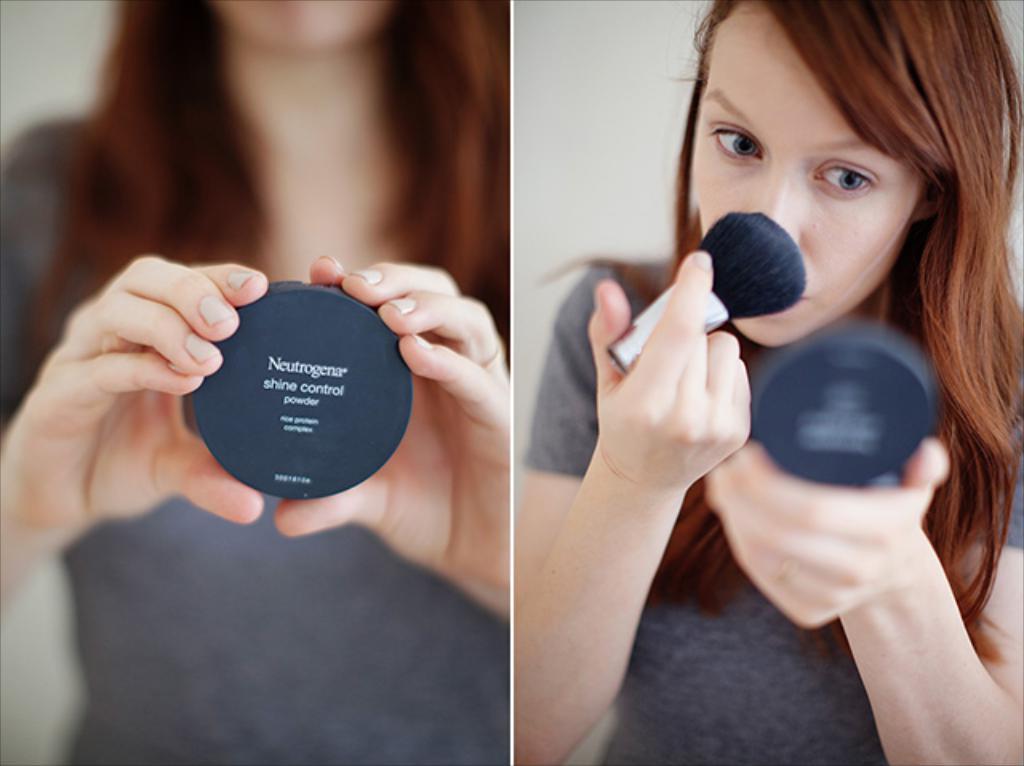What company made the makeup?
Offer a terse response. Neutrogena. What does it say on the label?
Keep it short and to the point. Neutrogena shine control powder. 